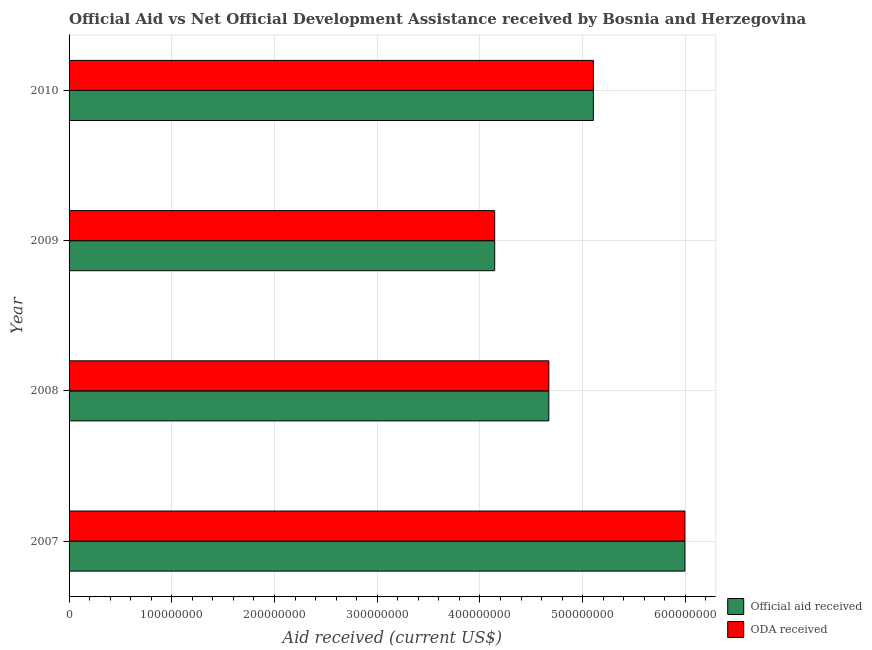How many different coloured bars are there?
Keep it short and to the point. 2. How many groups of bars are there?
Provide a succinct answer. 4. Are the number of bars on each tick of the Y-axis equal?
Provide a short and direct response. Yes. What is the label of the 2nd group of bars from the top?
Your answer should be very brief. 2009. What is the oda received in 2009?
Offer a very short reply. 4.14e+08. Across all years, what is the maximum oda received?
Ensure brevity in your answer.  5.99e+08. Across all years, what is the minimum official aid received?
Provide a succinct answer. 4.14e+08. What is the total official aid received in the graph?
Ensure brevity in your answer.  1.99e+09. What is the difference between the official aid received in 2007 and that in 2010?
Make the answer very short. 8.91e+07. What is the difference between the official aid received in 2008 and the oda received in 2010?
Ensure brevity in your answer.  -4.34e+07. What is the average oda received per year?
Your answer should be compact. 4.98e+08. In the year 2009, what is the difference between the official aid received and oda received?
Your response must be concise. 0. What is the ratio of the oda received in 2007 to that in 2010?
Provide a short and direct response. 1.18. What is the difference between the highest and the second highest official aid received?
Provide a short and direct response. 8.91e+07. What is the difference between the highest and the lowest oda received?
Keep it short and to the point. 1.85e+08. Is the sum of the official aid received in 2009 and 2010 greater than the maximum oda received across all years?
Provide a succinct answer. Yes. What does the 2nd bar from the top in 2008 represents?
Your response must be concise. Official aid received. What does the 2nd bar from the bottom in 2009 represents?
Your response must be concise. ODA received. How many bars are there?
Provide a succinct answer. 8. Are all the bars in the graph horizontal?
Give a very brief answer. Yes. What is the difference between two consecutive major ticks on the X-axis?
Your answer should be very brief. 1.00e+08. Are the values on the major ticks of X-axis written in scientific E-notation?
Your answer should be very brief. No. Does the graph contain any zero values?
Provide a short and direct response. No. Where does the legend appear in the graph?
Provide a short and direct response. Bottom right. How are the legend labels stacked?
Offer a terse response. Vertical. What is the title of the graph?
Give a very brief answer. Official Aid vs Net Official Development Assistance received by Bosnia and Herzegovina . What is the label or title of the X-axis?
Your answer should be very brief. Aid received (current US$). What is the label or title of the Y-axis?
Keep it short and to the point. Year. What is the Aid received (current US$) of Official aid received in 2007?
Your answer should be compact. 5.99e+08. What is the Aid received (current US$) of ODA received in 2007?
Make the answer very short. 5.99e+08. What is the Aid received (current US$) in Official aid received in 2008?
Ensure brevity in your answer.  4.67e+08. What is the Aid received (current US$) in ODA received in 2008?
Keep it short and to the point. 4.67e+08. What is the Aid received (current US$) of Official aid received in 2009?
Your answer should be compact. 4.14e+08. What is the Aid received (current US$) in ODA received in 2009?
Keep it short and to the point. 4.14e+08. What is the Aid received (current US$) of Official aid received in 2010?
Keep it short and to the point. 5.10e+08. What is the Aid received (current US$) in ODA received in 2010?
Make the answer very short. 5.10e+08. Across all years, what is the maximum Aid received (current US$) in Official aid received?
Your response must be concise. 5.99e+08. Across all years, what is the maximum Aid received (current US$) in ODA received?
Offer a very short reply. 5.99e+08. Across all years, what is the minimum Aid received (current US$) in Official aid received?
Offer a terse response. 4.14e+08. Across all years, what is the minimum Aid received (current US$) in ODA received?
Your answer should be compact. 4.14e+08. What is the total Aid received (current US$) in Official aid received in the graph?
Provide a succinct answer. 1.99e+09. What is the total Aid received (current US$) of ODA received in the graph?
Your answer should be compact. 1.99e+09. What is the difference between the Aid received (current US$) in Official aid received in 2007 and that in 2008?
Your answer should be compact. 1.32e+08. What is the difference between the Aid received (current US$) in ODA received in 2007 and that in 2008?
Offer a very short reply. 1.32e+08. What is the difference between the Aid received (current US$) of Official aid received in 2007 and that in 2009?
Give a very brief answer. 1.85e+08. What is the difference between the Aid received (current US$) in ODA received in 2007 and that in 2009?
Offer a terse response. 1.85e+08. What is the difference between the Aid received (current US$) of Official aid received in 2007 and that in 2010?
Make the answer very short. 8.91e+07. What is the difference between the Aid received (current US$) in ODA received in 2007 and that in 2010?
Offer a very short reply. 8.91e+07. What is the difference between the Aid received (current US$) of Official aid received in 2008 and that in 2009?
Your answer should be compact. 5.27e+07. What is the difference between the Aid received (current US$) in ODA received in 2008 and that in 2009?
Offer a terse response. 5.27e+07. What is the difference between the Aid received (current US$) of Official aid received in 2008 and that in 2010?
Make the answer very short. -4.34e+07. What is the difference between the Aid received (current US$) of ODA received in 2008 and that in 2010?
Offer a very short reply. -4.34e+07. What is the difference between the Aid received (current US$) of Official aid received in 2009 and that in 2010?
Offer a terse response. -9.60e+07. What is the difference between the Aid received (current US$) of ODA received in 2009 and that in 2010?
Give a very brief answer. -9.60e+07. What is the difference between the Aid received (current US$) of Official aid received in 2007 and the Aid received (current US$) of ODA received in 2008?
Your response must be concise. 1.32e+08. What is the difference between the Aid received (current US$) in Official aid received in 2007 and the Aid received (current US$) in ODA received in 2009?
Offer a very short reply. 1.85e+08. What is the difference between the Aid received (current US$) of Official aid received in 2007 and the Aid received (current US$) of ODA received in 2010?
Your response must be concise. 8.91e+07. What is the difference between the Aid received (current US$) in Official aid received in 2008 and the Aid received (current US$) in ODA received in 2009?
Ensure brevity in your answer.  5.27e+07. What is the difference between the Aid received (current US$) in Official aid received in 2008 and the Aid received (current US$) in ODA received in 2010?
Make the answer very short. -4.34e+07. What is the difference between the Aid received (current US$) of Official aid received in 2009 and the Aid received (current US$) of ODA received in 2010?
Offer a terse response. -9.60e+07. What is the average Aid received (current US$) of Official aid received per year?
Make the answer very short. 4.98e+08. What is the average Aid received (current US$) in ODA received per year?
Your answer should be compact. 4.98e+08. What is the ratio of the Aid received (current US$) in Official aid received in 2007 to that in 2008?
Keep it short and to the point. 1.28. What is the ratio of the Aid received (current US$) of ODA received in 2007 to that in 2008?
Offer a very short reply. 1.28. What is the ratio of the Aid received (current US$) of Official aid received in 2007 to that in 2009?
Give a very brief answer. 1.45. What is the ratio of the Aid received (current US$) in ODA received in 2007 to that in 2009?
Give a very brief answer. 1.45. What is the ratio of the Aid received (current US$) of Official aid received in 2007 to that in 2010?
Provide a succinct answer. 1.17. What is the ratio of the Aid received (current US$) of ODA received in 2007 to that in 2010?
Offer a terse response. 1.17. What is the ratio of the Aid received (current US$) of Official aid received in 2008 to that in 2009?
Ensure brevity in your answer.  1.13. What is the ratio of the Aid received (current US$) of ODA received in 2008 to that in 2009?
Offer a terse response. 1.13. What is the ratio of the Aid received (current US$) in Official aid received in 2008 to that in 2010?
Keep it short and to the point. 0.92. What is the ratio of the Aid received (current US$) in ODA received in 2008 to that in 2010?
Ensure brevity in your answer.  0.92. What is the ratio of the Aid received (current US$) in Official aid received in 2009 to that in 2010?
Provide a short and direct response. 0.81. What is the ratio of the Aid received (current US$) in ODA received in 2009 to that in 2010?
Your answer should be compact. 0.81. What is the difference between the highest and the second highest Aid received (current US$) in Official aid received?
Your response must be concise. 8.91e+07. What is the difference between the highest and the second highest Aid received (current US$) of ODA received?
Your answer should be compact. 8.91e+07. What is the difference between the highest and the lowest Aid received (current US$) of Official aid received?
Make the answer very short. 1.85e+08. What is the difference between the highest and the lowest Aid received (current US$) of ODA received?
Provide a succinct answer. 1.85e+08. 